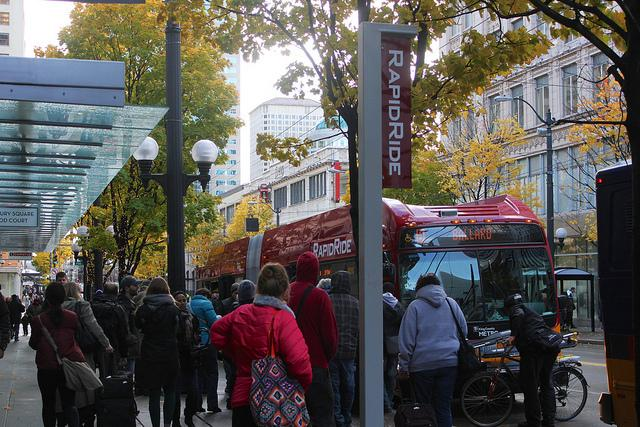What area is shown here? bus stop 